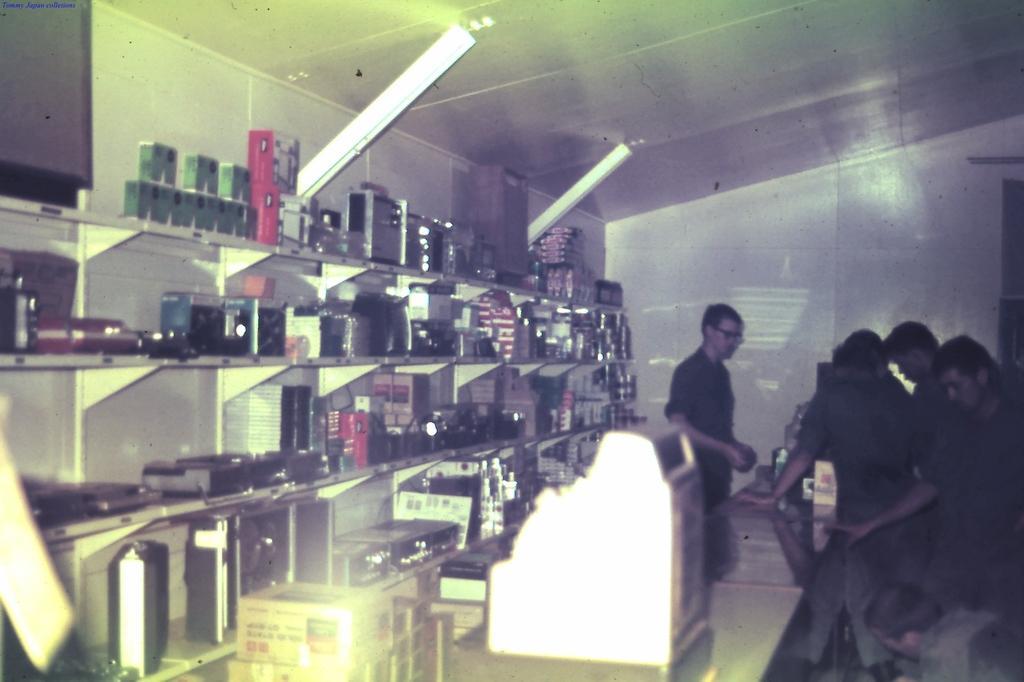Can you describe this image briefly? In the picture I can see few persons standing in the right corner and there is a table in front of them which has few objects placed on it and there is another person standing in front of them and there are few objects placed on shelves in the left corner. 